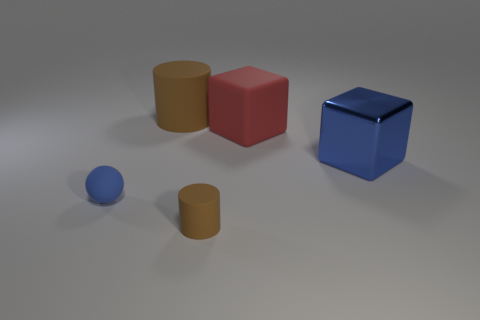Are there any other things that have the same material as the blue cube?
Offer a terse response. No. Are there fewer big brown matte things that are right of the big blue shiny cube than blue shiny cubes left of the blue sphere?
Your answer should be very brief. No. How many red things are either tiny rubber balls or big matte things?
Your answer should be compact. 1. Are there an equal number of cylinders in front of the big matte cylinder and cyan cubes?
Your answer should be very brief. No. What number of things are either tiny blue rubber things or brown matte cylinders that are to the right of the big matte cylinder?
Make the answer very short. 2. Do the large matte cylinder and the tiny matte cylinder have the same color?
Offer a very short reply. Yes. Are there any cyan objects made of the same material as the ball?
Keep it short and to the point. No. What is the color of the big rubber object that is the same shape as the small brown object?
Make the answer very short. Brown. Do the tiny brown cylinder and the object right of the red matte thing have the same material?
Your response must be concise. No. What is the shape of the brown thing in front of the small sphere that is on the left side of the large metallic thing?
Provide a short and direct response. Cylinder. 